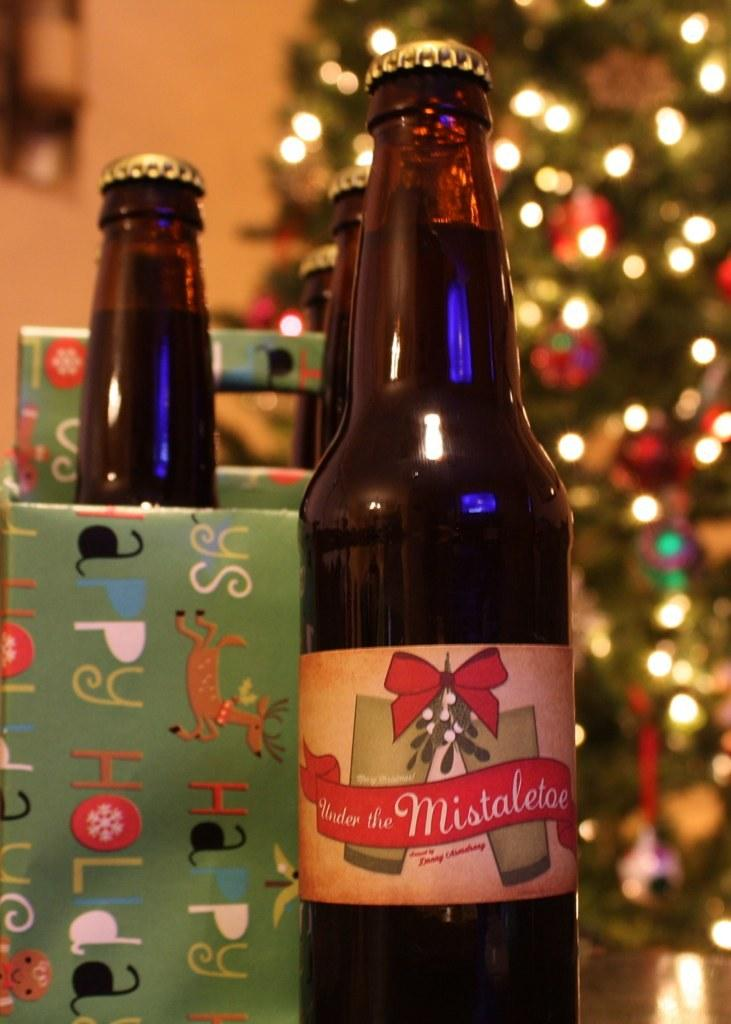<image>
Render a clear and concise summary of the photo. A bottle of Under the Mistaletoe beer is next to a holiday gift box with a lit up Christmas tree in the background. 